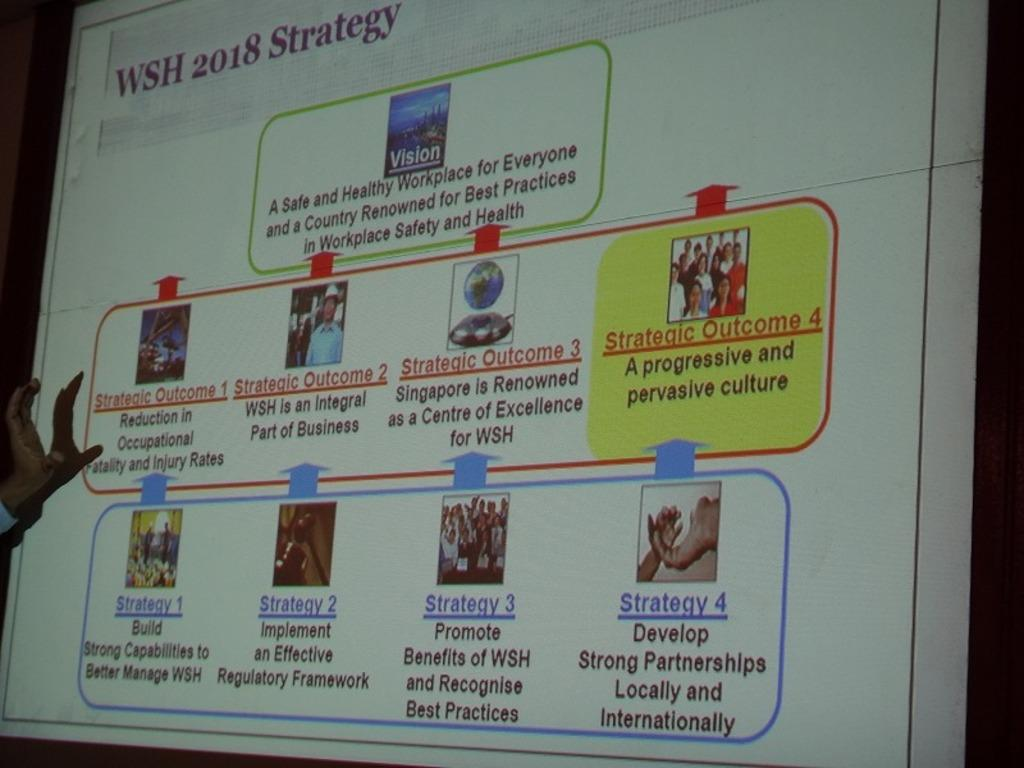<image>
Offer a succinct explanation of the picture presented. a presentation with strategy 4 written on it 